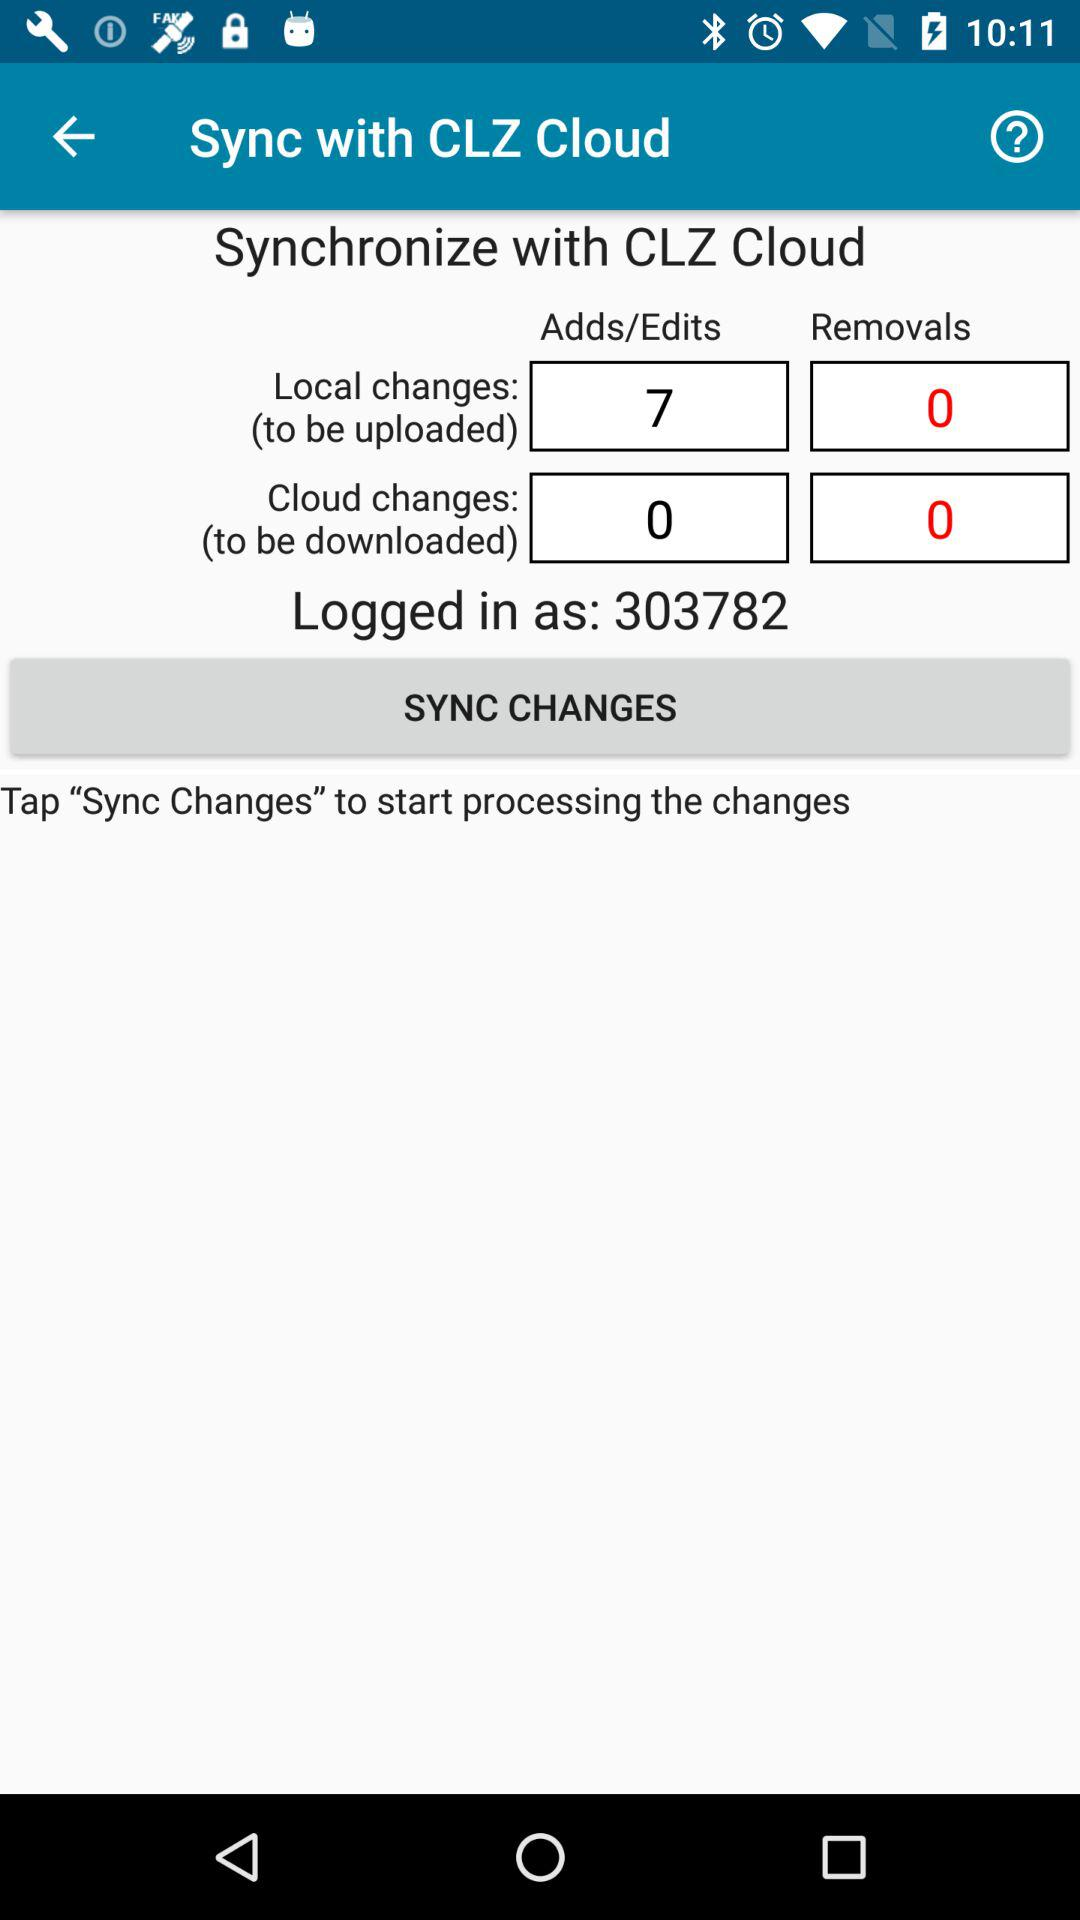How many more additions and edits are there than removals?
Answer the question using a single word or phrase. 7 